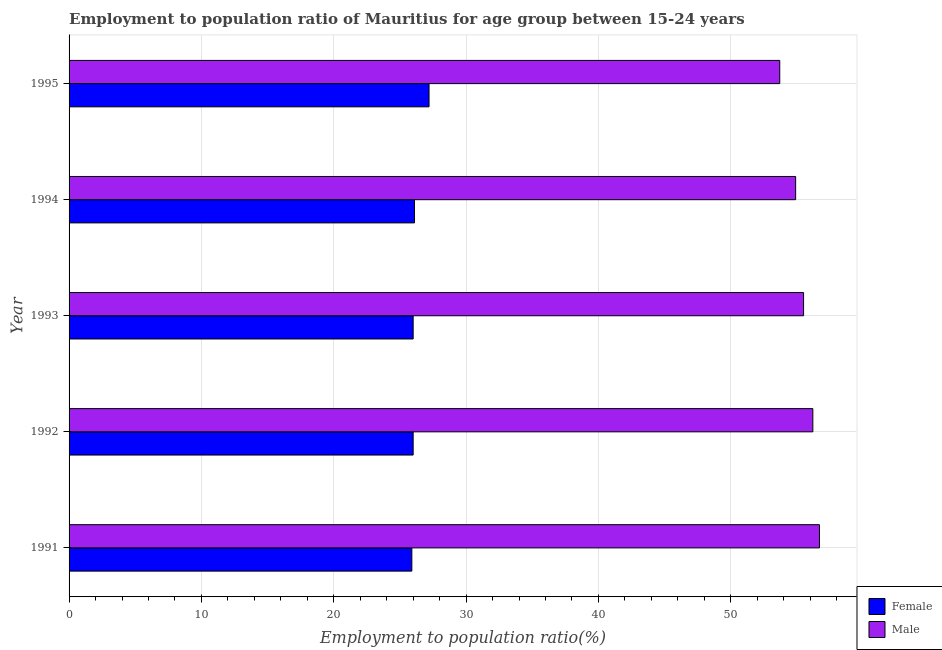How many different coloured bars are there?
Keep it short and to the point. 2. Are the number of bars per tick equal to the number of legend labels?
Your response must be concise. Yes. How many bars are there on the 3rd tick from the bottom?
Your answer should be compact. 2. What is the label of the 1st group of bars from the top?
Offer a terse response. 1995. In how many cases, is the number of bars for a given year not equal to the number of legend labels?
Your answer should be compact. 0. What is the employment to population ratio(male) in 1991?
Provide a succinct answer. 56.7. Across all years, what is the maximum employment to population ratio(female)?
Your response must be concise. 27.2. Across all years, what is the minimum employment to population ratio(female)?
Keep it short and to the point. 25.9. In which year was the employment to population ratio(female) maximum?
Provide a short and direct response. 1995. What is the total employment to population ratio(female) in the graph?
Give a very brief answer. 131.2. What is the difference between the employment to population ratio(female) in 1994 and that in 1995?
Your answer should be very brief. -1.1. What is the difference between the employment to population ratio(female) in 1991 and the employment to population ratio(male) in 1994?
Keep it short and to the point. -29. What is the average employment to population ratio(male) per year?
Your answer should be compact. 55.4. In how many years, is the employment to population ratio(male) greater than 16 %?
Your answer should be very brief. 5. Is the employment to population ratio(male) in 1992 less than that in 1993?
Your answer should be compact. No. In how many years, is the employment to population ratio(male) greater than the average employment to population ratio(male) taken over all years?
Ensure brevity in your answer.  3. How many years are there in the graph?
Make the answer very short. 5. Are the values on the major ticks of X-axis written in scientific E-notation?
Your answer should be very brief. No. How are the legend labels stacked?
Ensure brevity in your answer.  Vertical. What is the title of the graph?
Offer a very short reply. Employment to population ratio of Mauritius for age group between 15-24 years. Does "current US$" appear as one of the legend labels in the graph?
Offer a very short reply. No. What is the label or title of the X-axis?
Make the answer very short. Employment to population ratio(%). What is the Employment to population ratio(%) of Female in 1991?
Offer a terse response. 25.9. What is the Employment to population ratio(%) in Male in 1991?
Ensure brevity in your answer.  56.7. What is the Employment to population ratio(%) in Female in 1992?
Offer a terse response. 26. What is the Employment to population ratio(%) of Male in 1992?
Offer a terse response. 56.2. What is the Employment to population ratio(%) of Male in 1993?
Offer a very short reply. 55.5. What is the Employment to population ratio(%) in Female in 1994?
Keep it short and to the point. 26.1. What is the Employment to population ratio(%) of Male in 1994?
Provide a succinct answer. 54.9. What is the Employment to population ratio(%) in Female in 1995?
Your answer should be very brief. 27.2. What is the Employment to population ratio(%) of Male in 1995?
Your response must be concise. 53.7. Across all years, what is the maximum Employment to population ratio(%) of Female?
Your response must be concise. 27.2. Across all years, what is the maximum Employment to population ratio(%) in Male?
Your answer should be very brief. 56.7. Across all years, what is the minimum Employment to population ratio(%) of Female?
Provide a short and direct response. 25.9. Across all years, what is the minimum Employment to population ratio(%) of Male?
Offer a very short reply. 53.7. What is the total Employment to population ratio(%) in Female in the graph?
Your answer should be compact. 131.2. What is the total Employment to population ratio(%) in Male in the graph?
Ensure brevity in your answer.  277. What is the difference between the Employment to population ratio(%) in Male in 1991 and that in 1992?
Ensure brevity in your answer.  0.5. What is the difference between the Employment to population ratio(%) of Female in 1991 and that in 1993?
Offer a very short reply. -0.1. What is the difference between the Employment to population ratio(%) of Male in 1991 and that in 1993?
Make the answer very short. 1.2. What is the difference between the Employment to population ratio(%) of Male in 1991 and that in 1994?
Keep it short and to the point. 1.8. What is the difference between the Employment to population ratio(%) in Female in 1991 and that in 1995?
Your response must be concise. -1.3. What is the difference between the Employment to population ratio(%) of Male in 1991 and that in 1995?
Ensure brevity in your answer.  3. What is the difference between the Employment to population ratio(%) of Female in 1992 and that in 1993?
Your answer should be compact. 0. What is the difference between the Employment to population ratio(%) in Male in 1992 and that in 1993?
Make the answer very short. 0.7. What is the difference between the Employment to population ratio(%) in Female in 1992 and that in 1994?
Provide a succinct answer. -0.1. What is the difference between the Employment to population ratio(%) of Male in 1992 and that in 1994?
Offer a very short reply. 1.3. What is the difference between the Employment to population ratio(%) of Female in 1992 and that in 1995?
Your response must be concise. -1.2. What is the difference between the Employment to population ratio(%) in Female in 1993 and that in 1994?
Ensure brevity in your answer.  -0.1. What is the difference between the Employment to population ratio(%) in Male in 1993 and that in 1994?
Keep it short and to the point. 0.6. What is the difference between the Employment to population ratio(%) in Male in 1994 and that in 1995?
Provide a short and direct response. 1.2. What is the difference between the Employment to population ratio(%) in Female in 1991 and the Employment to population ratio(%) in Male in 1992?
Provide a succinct answer. -30.3. What is the difference between the Employment to population ratio(%) in Female in 1991 and the Employment to population ratio(%) in Male in 1993?
Provide a succinct answer. -29.6. What is the difference between the Employment to population ratio(%) in Female in 1991 and the Employment to population ratio(%) in Male in 1995?
Your answer should be compact. -27.8. What is the difference between the Employment to population ratio(%) of Female in 1992 and the Employment to population ratio(%) of Male in 1993?
Ensure brevity in your answer.  -29.5. What is the difference between the Employment to population ratio(%) of Female in 1992 and the Employment to population ratio(%) of Male in 1994?
Your answer should be very brief. -28.9. What is the difference between the Employment to population ratio(%) in Female in 1992 and the Employment to population ratio(%) in Male in 1995?
Keep it short and to the point. -27.7. What is the difference between the Employment to population ratio(%) in Female in 1993 and the Employment to population ratio(%) in Male in 1994?
Keep it short and to the point. -28.9. What is the difference between the Employment to population ratio(%) in Female in 1993 and the Employment to population ratio(%) in Male in 1995?
Your response must be concise. -27.7. What is the difference between the Employment to population ratio(%) of Female in 1994 and the Employment to population ratio(%) of Male in 1995?
Your answer should be very brief. -27.6. What is the average Employment to population ratio(%) of Female per year?
Your answer should be compact. 26.24. What is the average Employment to population ratio(%) in Male per year?
Make the answer very short. 55.4. In the year 1991, what is the difference between the Employment to population ratio(%) in Female and Employment to population ratio(%) in Male?
Give a very brief answer. -30.8. In the year 1992, what is the difference between the Employment to population ratio(%) in Female and Employment to population ratio(%) in Male?
Your answer should be very brief. -30.2. In the year 1993, what is the difference between the Employment to population ratio(%) in Female and Employment to population ratio(%) in Male?
Provide a short and direct response. -29.5. In the year 1994, what is the difference between the Employment to population ratio(%) of Female and Employment to population ratio(%) of Male?
Offer a very short reply. -28.8. In the year 1995, what is the difference between the Employment to population ratio(%) of Female and Employment to population ratio(%) of Male?
Offer a terse response. -26.5. What is the ratio of the Employment to population ratio(%) of Female in 1991 to that in 1992?
Ensure brevity in your answer.  1. What is the ratio of the Employment to population ratio(%) of Male in 1991 to that in 1992?
Provide a short and direct response. 1.01. What is the ratio of the Employment to population ratio(%) of Male in 1991 to that in 1993?
Your answer should be very brief. 1.02. What is the ratio of the Employment to population ratio(%) in Female in 1991 to that in 1994?
Provide a short and direct response. 0.99. What is the ratio of the Employment to population ratio(%) in Male in 1991 to that in 1994?
Make the answer very short. 1.03. What is the ratio of the Employment to population ratio(%) in Female in 1991 to that in 1995?
Your response must be concise. 0.95. What is the ratio of the Employment to population ratio(%) of Male in 1991 to that in 1995?
Ensure brevity in your answer.  1.06. What is the ratio of the Employment to population ratio(%) of Female in 1992 to that in 1993?
Provide a succinct answer. 1. What is the ratio of the Employment to population ratio(%) of Male in 1992 to that in 1993?
Provide a short and direct response. 1.01. What is the ratio of the Employment to population ratio(%) in Female in 1992 to that in 1994?
Provide a short and direct response. 1. What is the ratio of the Employment to population ratio(%) of Male in 1992 to that in 1994?
Your answer should be compact. 1.02. What is the ratio of the Employment to population ratio(%) in Female in 1992 to that in 1995?
Your answer should be very brief. 0.96. What is the ratio of the Employment to population ratio(%) of Male in 1992 to that in 1995?
Provide a short and direct response. 1.05. What is the ratio of the Employment to population ratio(%) of Male in 1993 to that in 1994?
Your answer should be very brief. 1.01. What is the ratio of the Employment to population ratio(%) of Female in 1993 to that in 1995?
Offer a very short reply. 0.96. What is the ratio of the Employment to population ratio(%) of Male in 1993 to that in 1995?
Provide a short and direct response. 1.03. What is the ratio of the Employment to population ratio(%) of Female in 1994 to that in 1995?
Ensure brevity in your answer.  0.96. What is the ratio of the Employment to population ratio(%) in Male in 1994 to that in 1995?
Offer a very short reply. 1.02. What is the difference between the highest and the second highest Employment to population ratio(%) in Female?
Give a very brief answer. 1.1. What is the difference between the highest and the lowest Employment to population ratio(%) of Male?
Keep it short and to the point. 3. 